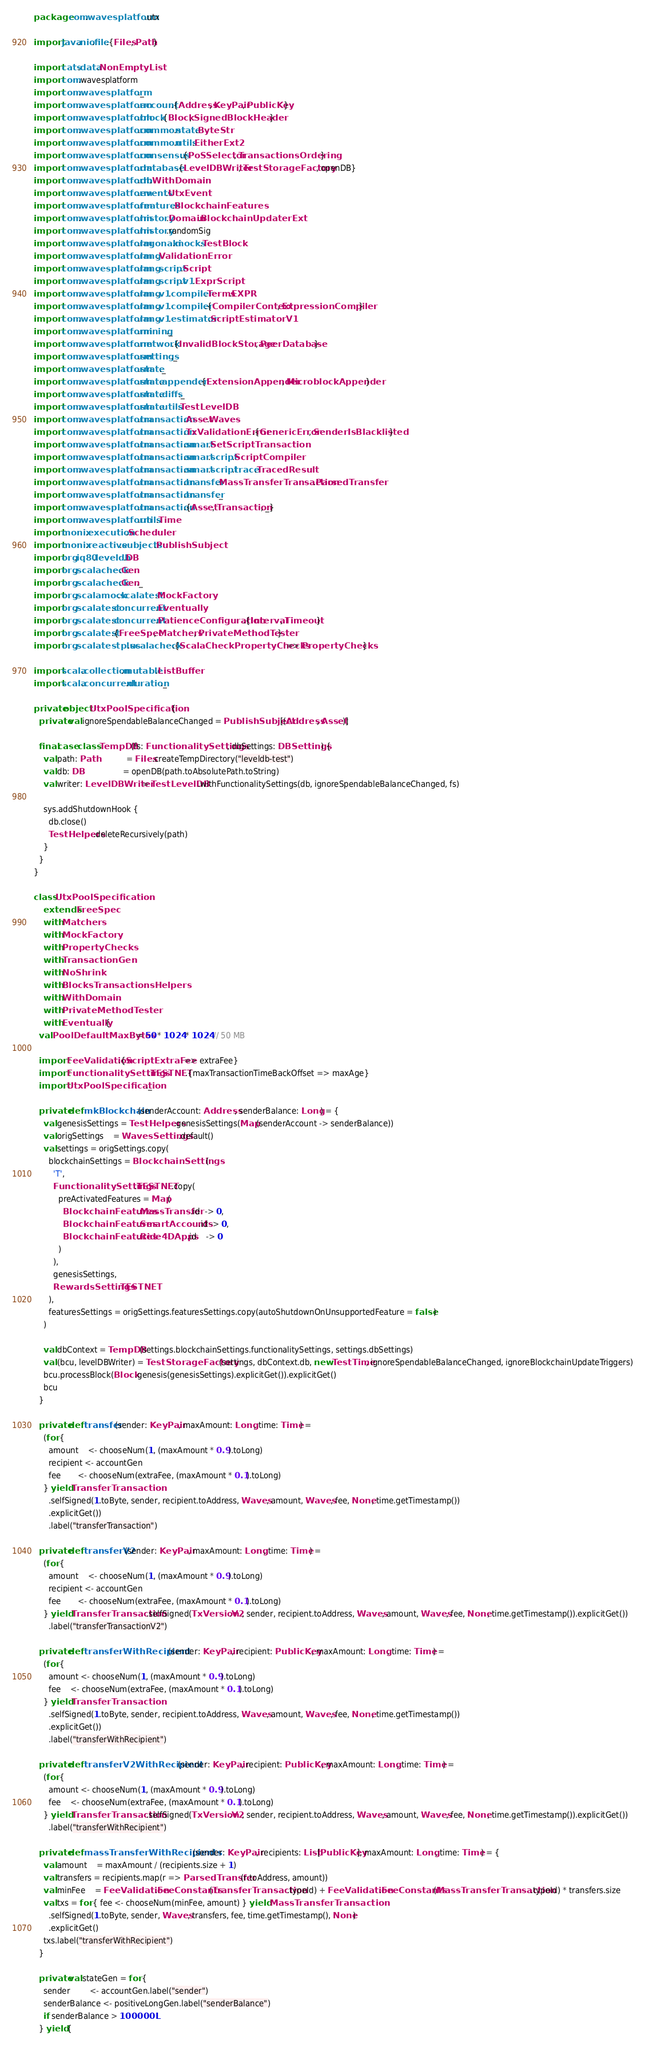<code> <loc_0><loc_0><loc_500><loc_500><_Scala_>package com.wavesplatform.utx

import java.nio.file.{Files, Path}

import cats.data.NonEmptyList
import com.wavesplatform
import com.wavesplatform._
import com.wavesplatform.account.{Address, KeyPair, PublicKey}
import com.wavesplatform.block.{Block, SignedBlockHeader}
import com.wavesplatform.common.state.ByteStr
import com.wavesplatform.common.utils.EitherExt2
import com.wavesplatform.consensus.{PoSSelector, TransactionsOrdering}
import com.wavesplatform.database.{LevelDBWriter, TestStorageFactory, openDB}
import com.wavesplatform.db.WithDomain
import com.wavesplatform.events.UtxEvent
import com.wavesplatform.features.BlockchainFeatures
import com.wavesplatform.history.Domain.BlockchainUpdaterExt
import com.wavesplatform.history.randomSig
import com.wavesplatform.lagonaki.mocks.TestBlock
import com.wavesplatform.lang.ValidationError
import com.wavesplatform.lang.script.Script
import com.wavesplatform.lang.script.v1.ExprScript
import com.wavesplatform.lang.v1.compiler.Terms.EXPR
import com.wavesplatform.lang.v1.compiler.{CompilerContext, ExpressionCompiler}
import com.wavesplatform.lang.v1.estimator.ScriptEstimatorV1
import com.wavesplatform.mining._
import com.wavesplatform.network.{InvalidBlockStorage, PeerDatabase}
import com.wavesplatform.settings._
import com.wavesplatform.state._
import com.wavesplatform.state.appender.{ExtensionAppender, MicroblockAppender}
import com.wavesplatform.state.diffs._
import com.wavesplatform.state.utils.TestLevelDB
import com.wavesplatform.transaction.Asset.Waves
import com.wavesplatform.transaction.TxValidationError.{GenericError, SenderIsBlacklisted}
import com.wavesplatform.transaction.smart.SetScriptTransaction
import com.wavesplatform.transaction.smart.script.ScriptCompiler
import com.wavesplatform.transaction.smart.script.trace.TracedResult
import com.wavesplatform.transaction.transfer.MassTransferTransaction.ParsedTransfer
import com.wavesplatform.transaction.transfer._
import com.wavesplatform.transaction.{Asset, Transaction, _}
import com.wavesplatform.utils.Time
import monix.execution.Scheduler
import monix.reactive.subjects.PublishSubject
import org.iq80.leveldb.DB
import org.scalacheck.Gen
import org.scalacheck.Gen._
import org.scalamock.scalatest.MockFactory
import org.scalatest.concurrent.Eventually
import org.scalatest.concurrent.PatienceConfiguration.{Interval, Timeout}
import org.scalatest.{FreeSpec, Matchers, PrivateMethodTester}
import org.scalatestplus.scalacheck.{ScalaCheckPropertyChecks => PropertyChecks}

import scala.collection.mutable.ListBuffer
import scala.concurrent.duration._

private object UtxPoolSpecification {
  private val ignoreSpendableBalanceChanged = PublishSubject[(Address, Asset)]

  final case class TempDB(fs: FunctionalitySettings, dbSettings: DBSettings) {
    val path: Path            = Files.createTempDirectory("leveldb-test")
    val db: DB                = openDB(path.toAbsolutePath.toString)
    val writer: LevelDBWriter = TestLevelDB.withFunctionalitySettings(db, ignoreSpendableBalanceChanged, fs)

    sys.addShutdownHook {
      db.close()
      TestHelpers.deleteRecursively(path)
    }
  }
}

class UtxPoolSpecification
    extends FreeSpec
    with Matchers
    with MockFactory
    with PropertyChecks
    with TransactionGen
    with NoShrink
    with BlocksTransactionsHelpers
    with WithDomain
    with PrivateMethodTester
    with Eventually {
  val PoolDefaultMaxBytes = 50 * 1024 * 1024 // 50 MB

  import FeeValidation.{ScriptExtraFee => extraFee}
  import FunctionalitySettings.TESTNET.{maxTransactionTimeBackOffset => maxAge}
  import UtxPoolSpecification._

  private def mkBlockchain(senderAccount: Address, senderBalance: Long) = {
    val genesisSettings = TestHelpers.genesisSettings(Map(senderAccount -> senderBalance))
    val origSettings    = WavesSettings.default()
    val settings = origSettings.copy(
      blockchainSettings = BlockchainSettings(
        'T',
        FunctionalitySettings.TESTNET.copy(
          preActivatedFeatures = Map(
            BlockchainFeatures.MassTransfer.id  -> 0,
            BlockchainFeatures.SmartAccounts.id -> 0,
            BlockchainFeatures.Ride4DApps.id    -> 0
          )
        ),
        genesisSettings,
        RewardsSettings.TESTNET
      ),
      featuresSettings = origSettings.featuresSettings.copy(autoShutdownOnUnsupportedFeature = false)
    )

    val dbContext = TempDB(settings.blockchainSettings.functionalitySettings, settings.dbSettings)
    val (bcu, levelDBWriter) = TestStorageFactory(settings, dbContext.db, new TestTime, ignoreSpendableBalanceChanged, ignoreBlockchainUpdateTriggers)
    bcu.processBlock(Block.genesis(genesisSettings).explicitGet()).explicitGet()
    bcu
  }

  private def transfer(sender: KeyPair, maxAmount: Long, time: Time) =
    (for {
      amount    <- chooseNum(1, (maxAmount * 0.9).toLong)
      recipient <- accountGen
      fee       <- chooseNum(extraFee, (maxAmount * 0.1).toLong)
    } yield TransferTransaction
      .selfSigned(1.toByte, sender, recipient.toAddress, Waves, amount, Waves, fee, None, time.getTimestamp())
      .explicitGet())
      .label("transferTransaction")

  private def transferV2(sender: KeyPair, maxAmount: Long, time: Time) =
    (for {
      amount    <- chooseNum(1, (maxAmount * 0.9).toLong)
      recipient <- accountGen
      fee       <- chooseNum(extraFee, (maxAmount * 0.1).toLong)
    } yield TransferTransaction.selfSigned(TxVersion.V2, sender, recipient.toAddress, Waves, amount, Waves, fee, None, time.getTimestamp()).explicitGet())
      .label("transferTransactionV2")

  private def transferWithRecipient(sender: KeyPair, recipient: PublicKey, maxAmount: Long, time: Time) =
    (for {
      amount <- chooseNum(1, (maxAmount * 0.9).toLong)
      fee    <- chooseNum(extraFee, (maxAmount * 0.1).toLong)
    } yield TransferTransaction
      .selfSigned(1.toByte, sender, recipient.toAddress, Waves, amount, Waves, fee, None, time.getTimestamp())
      .explicitGet())
      .label("transferWithRecipient")

  private def transferV2WithRecipient(sender: KeyPair, recipient: PublicKey, maxAmount: Long, time: Time) =
    (for {
      amount <- chooseNum(1, (maxAmount * 0.9).toLong)
      fee    <- chooseNum(extraFee, (maxAmount * 0.1).toLong)
    } yield TransferTransaction.selfSigned(TxVersion.V2, sender, recipient.toAddress, Waves, amount, Waves, fee, None, time.getTimestamp()).explicitGet())
      .label("transferWithRecipient")

  private def massTransferWithRecipients(sender: KeyPair, recipients: List[PublicKey], maxAmount: Long, time: Time) = {
    val amount    = maxAmount / (recipients.size + 1)
    val transfers = recipients.map(r => ParsedTransfer(r.toAddress, amount))
    val minFee    = FeeValidation.FeeConstants(TransferTransaction.typeId) + FeeValidation.FeeConstants(MassTransferTransaction.typeId) * transfers.size
    val txs = for { fee <- chooseNum(minFee, amount) } yield MassTransferTransaction
      .selfSigned(1.toByte, sender, Waves, transfers, fee, time.getTimestamp(), None)
      .explicitGet()
    txs.label("transferWithRecipient")
  }

  private val stateGen = for {
    sender        <- accountGen.label("sender")
    senderBalance <- positiveLongGen.label("senderBalance")
    if senderBalance > 100000L
  } yield {</code> 